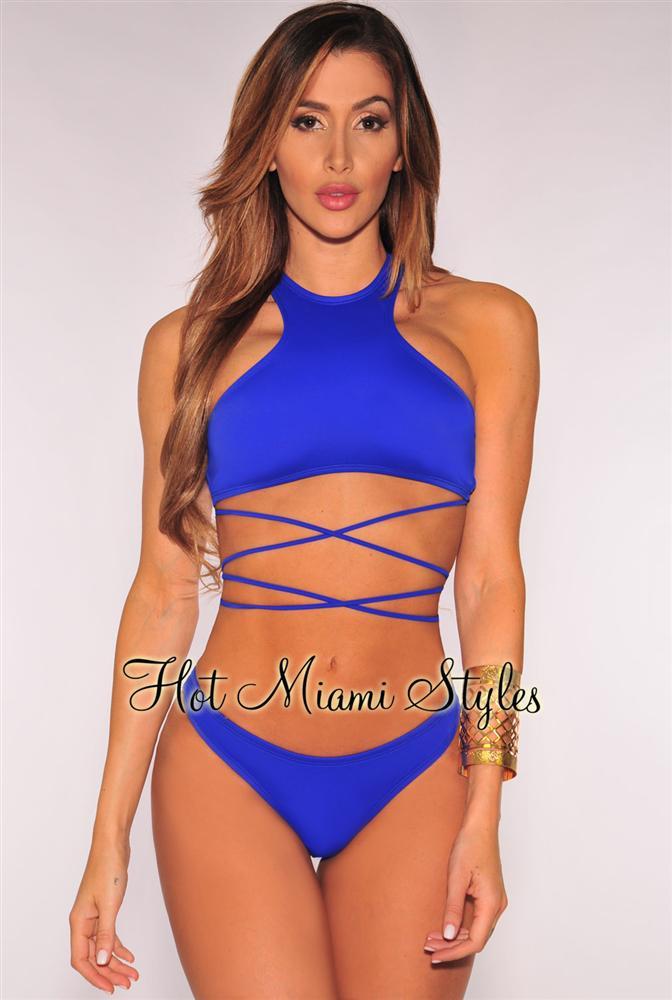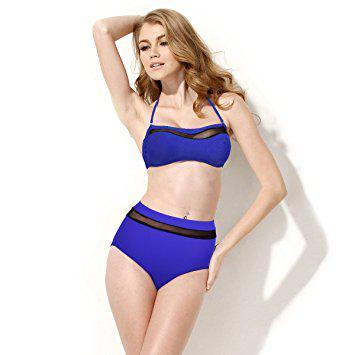The first image is the image on the left, the second image is the image on the right. For the images shown, is this caption "In one image, a woman is wearing a necklace." true? Answer yes or no. No. The first image is the image on the left, the second image is the image on the right. Analyze the images presented: Is the assertion "models are wearing high wasted bikini bottoms" valid? Answer yes or no. Yes. 